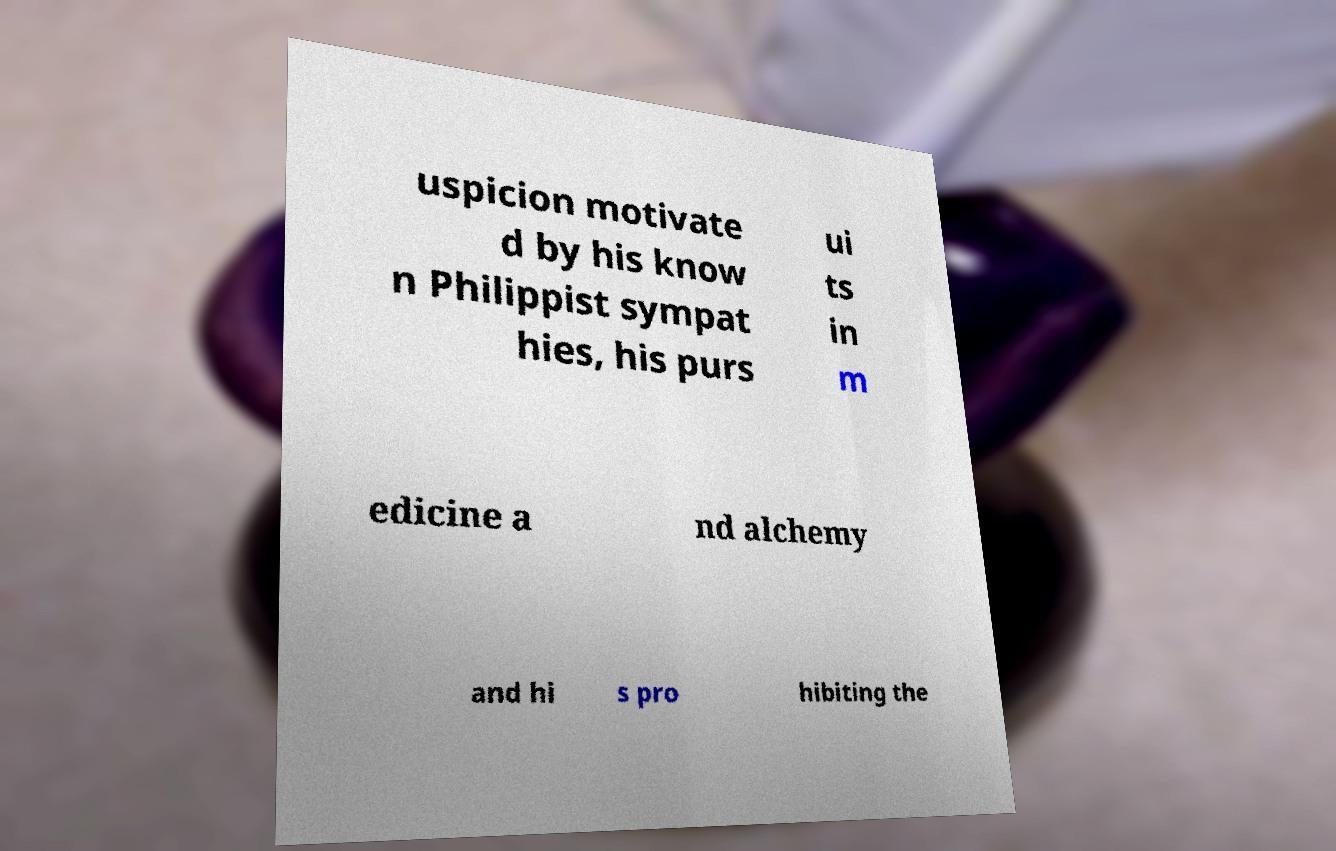Can you read and provide the text displayed in the image?This photo seems to have some interesting text. Can you extract and type it out for me? uspicion motivate d by his know n Philippist sympat hies, his purs ui ts in m edicine a nd alchemy and hi s pro hibiting the 